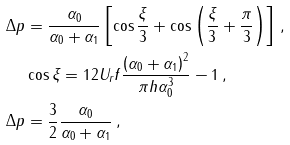Convert formula to latex. <formula><loc_0><loc_0><loc_500><loc_500>\Delta p & = \frac { \alpha _ { 0 } } { \alpha _ { 0 } + \alpha _ { 1 } } \left [ \cos \frac { \xi } { 3 } + \cos \left ( \frac { \xi } { 3 } + \frac { \pi } { 3 } \right ) \right ] \, , \\ & \cos \xi = 1 2 U _ { r } f \frac { \left ( \alpha _ { 0 } + \alpha _ { 1 } \right ) ^ { 2 } } { \pi h \alpha ^ { 3 } _ { 0 } } - 1 \, , \\ \Delta p & = \frac { 3 } { 2 } \frac { \alpha _ { 0 } } { \alpha _ { 0 } + \alpha _ { 1 } } \, ,</formula> 